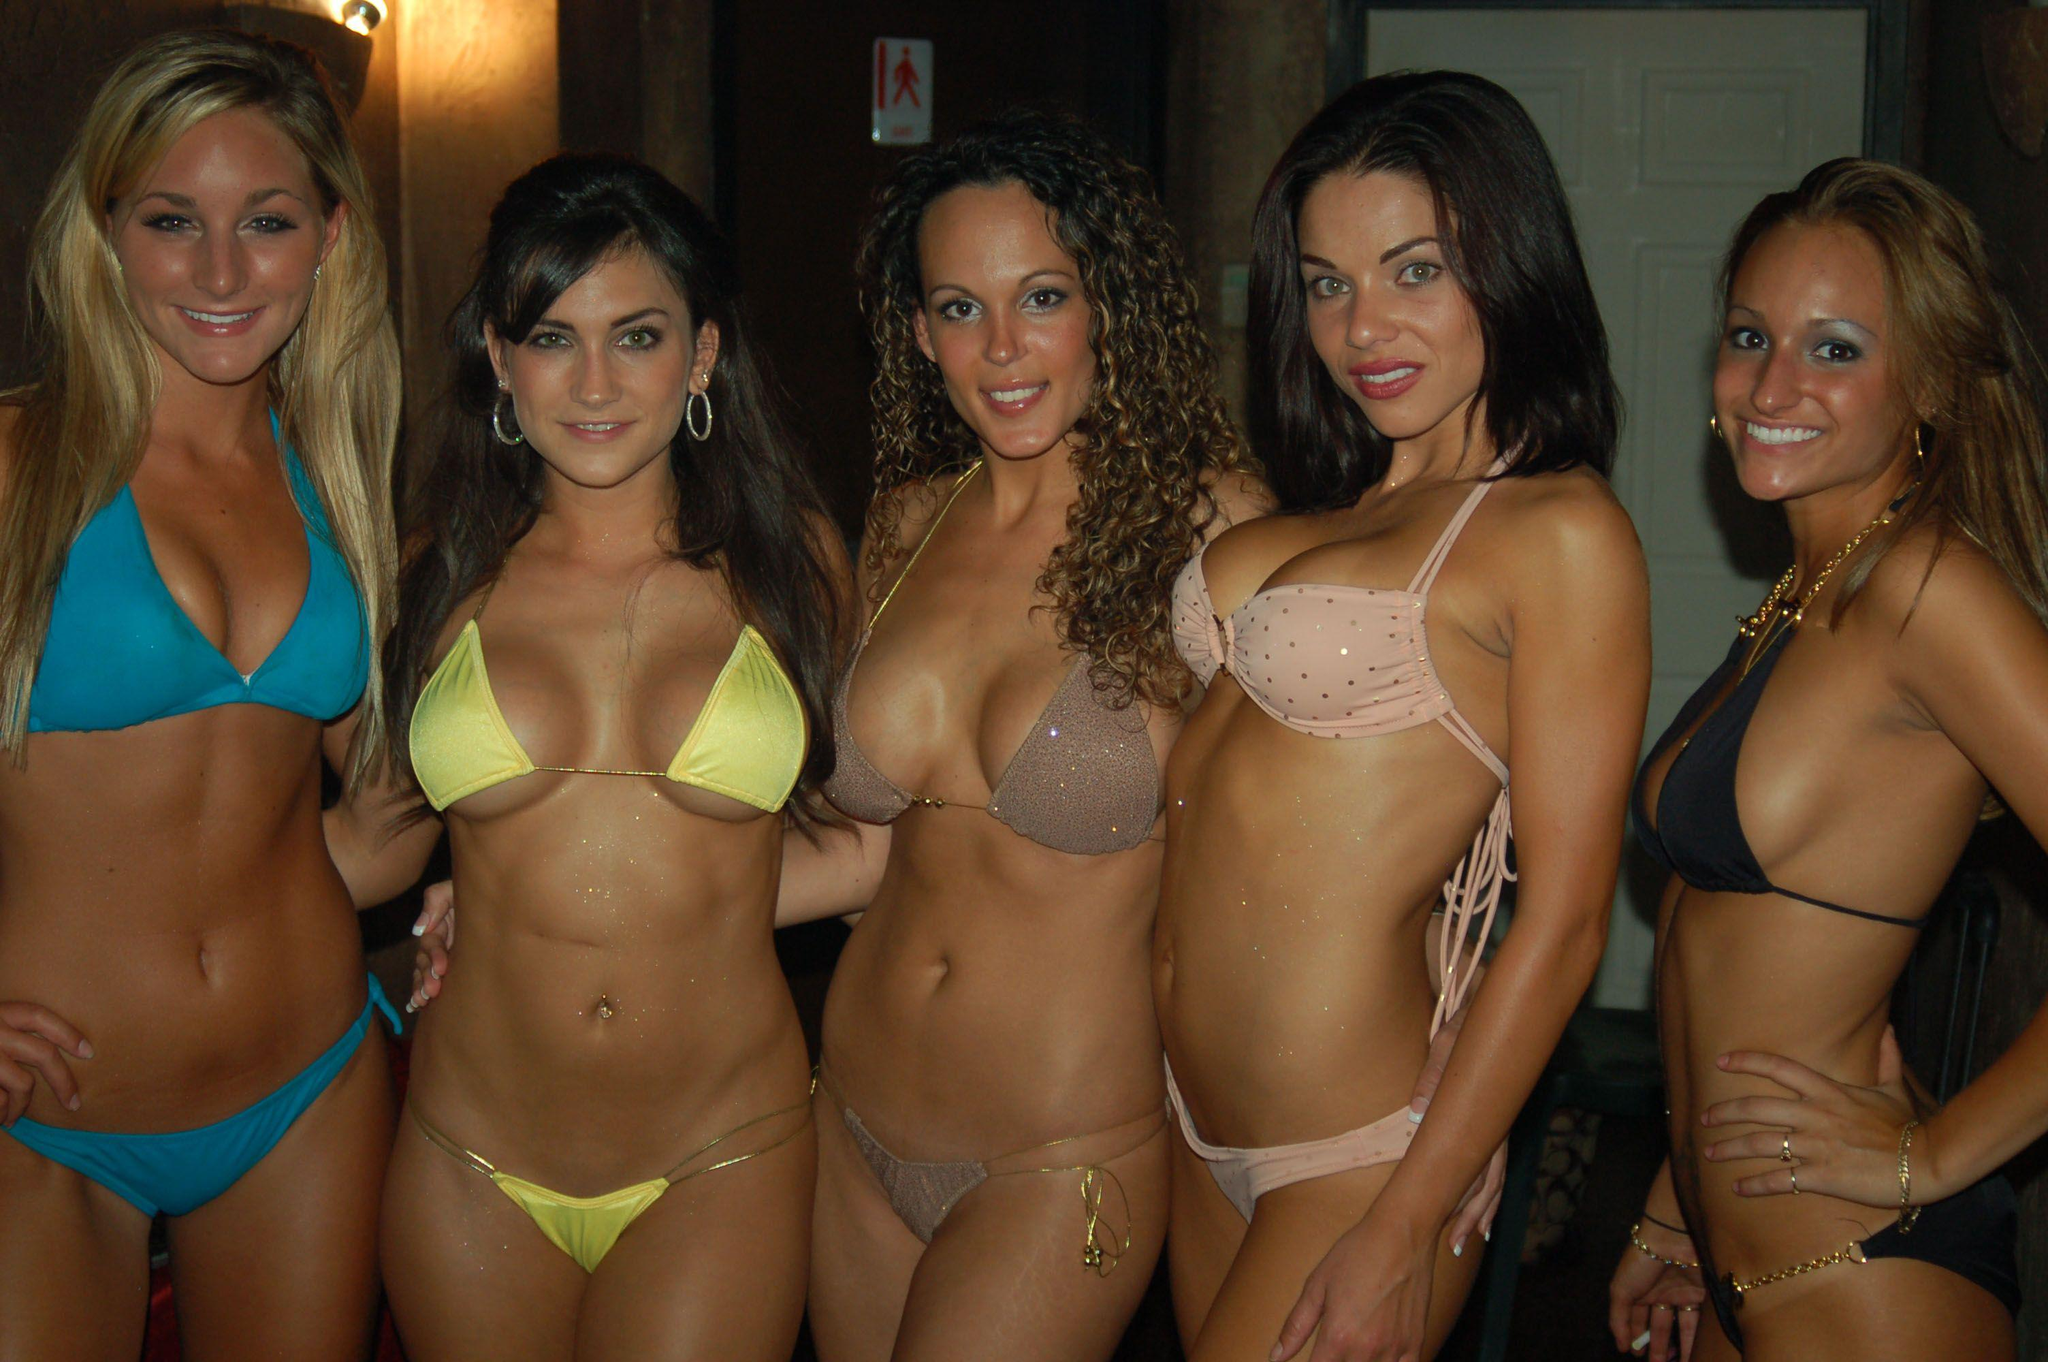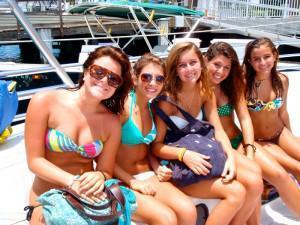The first image is the image on the left, the second image is the image on the right. For the images displayed, is the sentence "There are 6 women lined up for a photo in the left image." factually correct? Answer yes or no. No. The first image is the image on the left, the second image is the image on the right. Examine the images to the left and right. Is the description "The left and right image contains a total of 13 women in bikinis." accurate? Answer yes or no. No. 